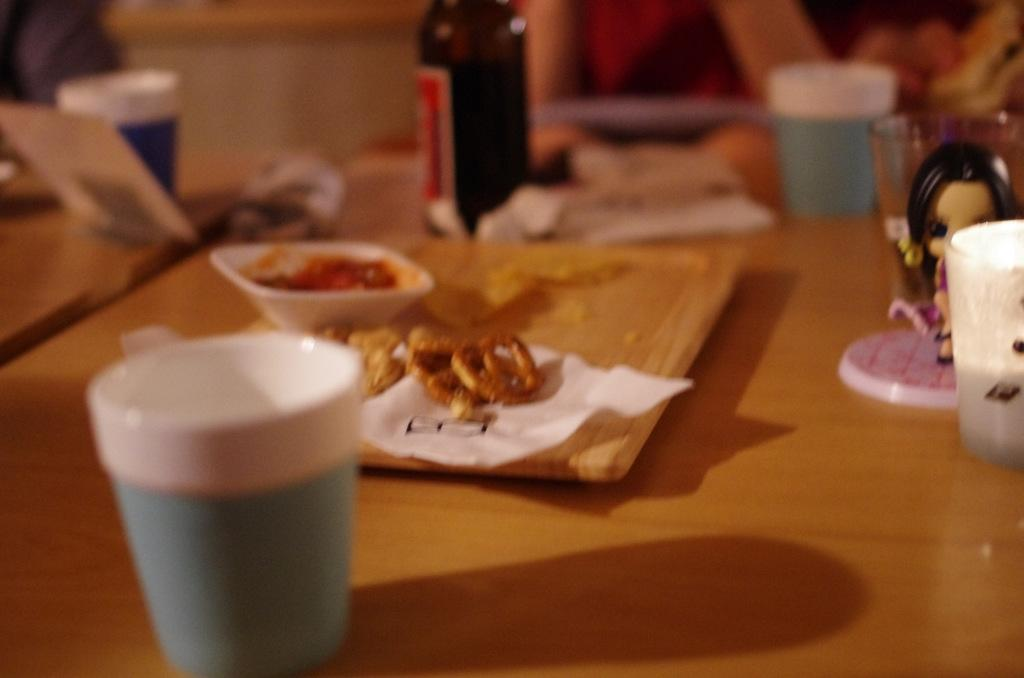Where was the image taken? The image was taken inside a room. What furniture is present in the room? There is a table in the room. What items can be seen on the table? There is a cup, a tray, a bowl with sauce and food, and a bottle on the table. What type of leaf is used as a decoration on the table in the image? There is no leaf present on the table in the image. How many beans are visible in the bowl with sauce and food? There is no mention of beans in the bowl with sauce and food in the image. 